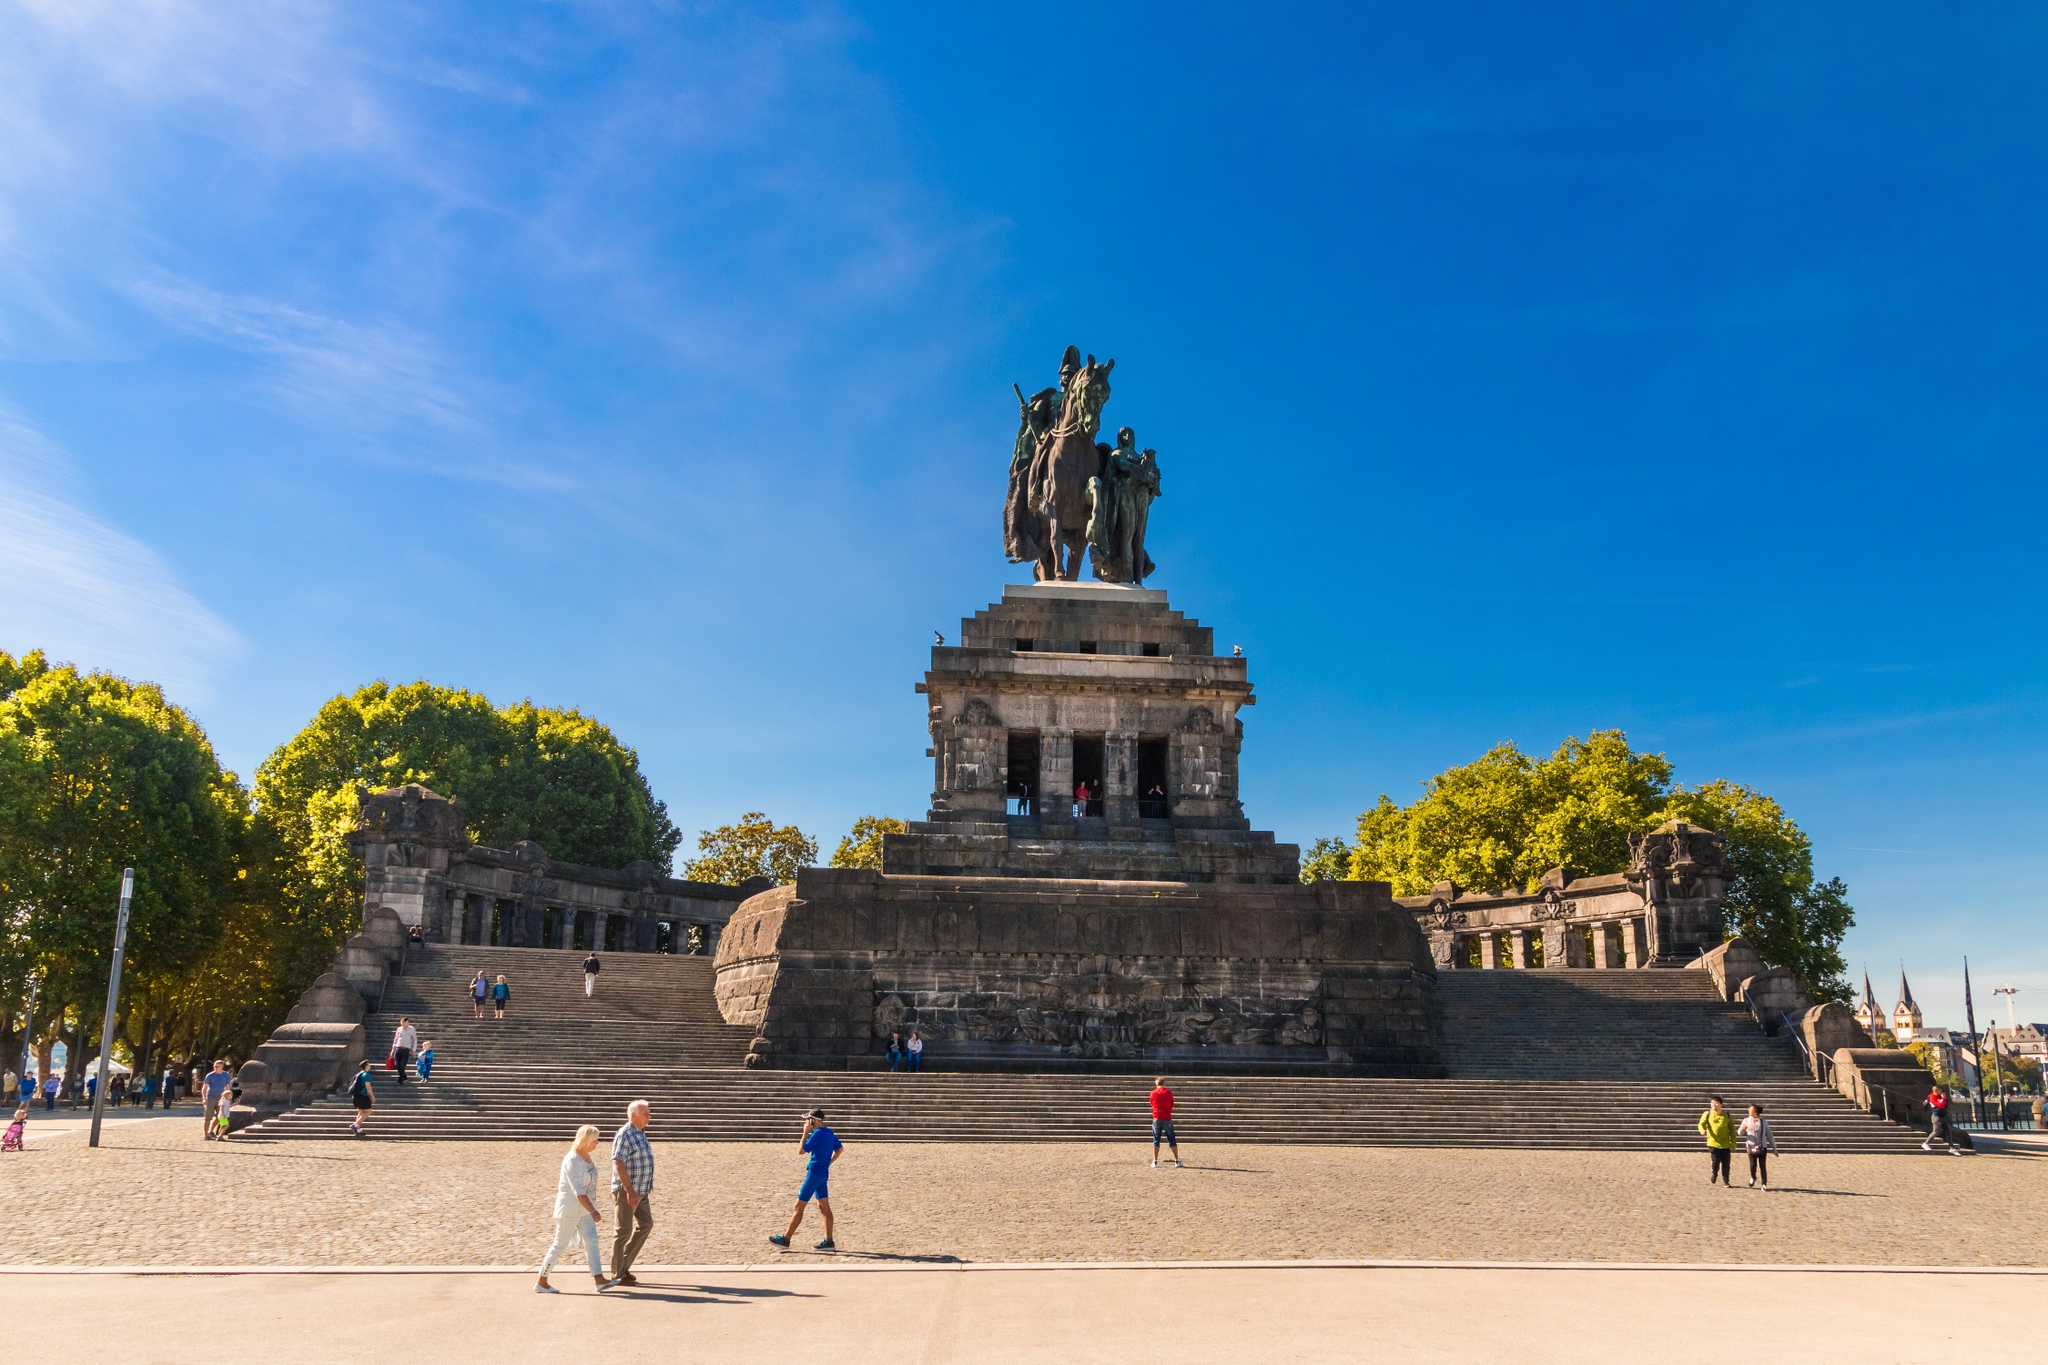Tell me more about the people visiting the monument. The monument is a magnet for visitors from all walks of life. In the image, you can see families, tourists, and locals alike. Some are leisurely strolling, perhaps enjoying a day out, while others are more immersed in the historical significance of the site. The steps provide a perfect respite for those looking to relax and take in the grandeur of Deutsches Eck, making it a hub for both recreation and reflection. The mix of generations and cultures seen in this image highlights the universal appeal and importance of this landmark. 